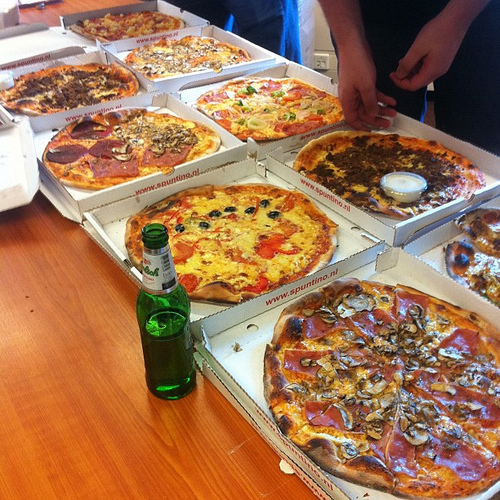Are there both mushrooms and mangos in this scene? No, there are no mangos in this scene, only mushrooms. 